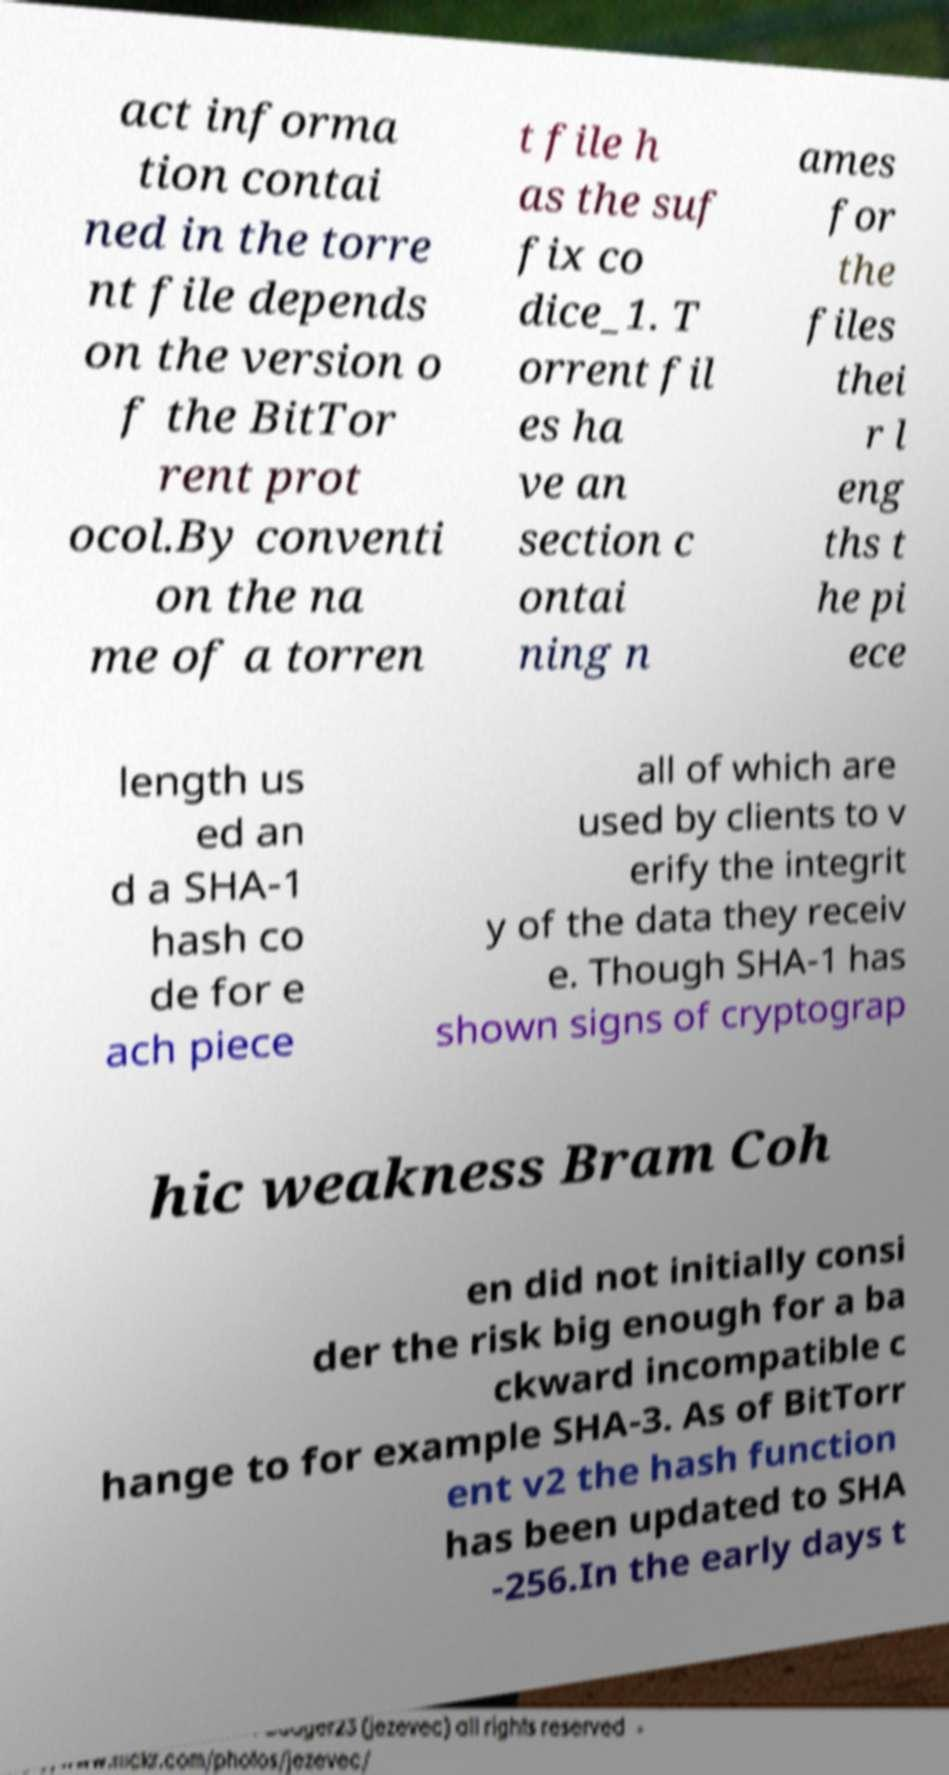Can you read and provide the text displayed in the image?This photo seems to have some interesting text. Can you extract and type it out for me? act informa tion contai ned in the torre nt file depends on the version o f the BitTor rent prot ocol.By conventi on the na me of a torren t file h as the suf fix co dice_1. T orrent fil es ha ve an section c ontai ning n ames for the files thei r l eng ths t he pi ece length us ed an d a SHA-1 hash co de for e ach piece all of which are used by clients to v erify the integrit y of the data they receiv e. Though SHA-1 has shown signs of cryptograp hic weakness Bram Coh en did not initially consi der the risk big enough for a ba ckward incompatible c hange to for example SHA-3. As of BitTorr ent v2 the hash function has been updated to SHA -256.In the early days t 